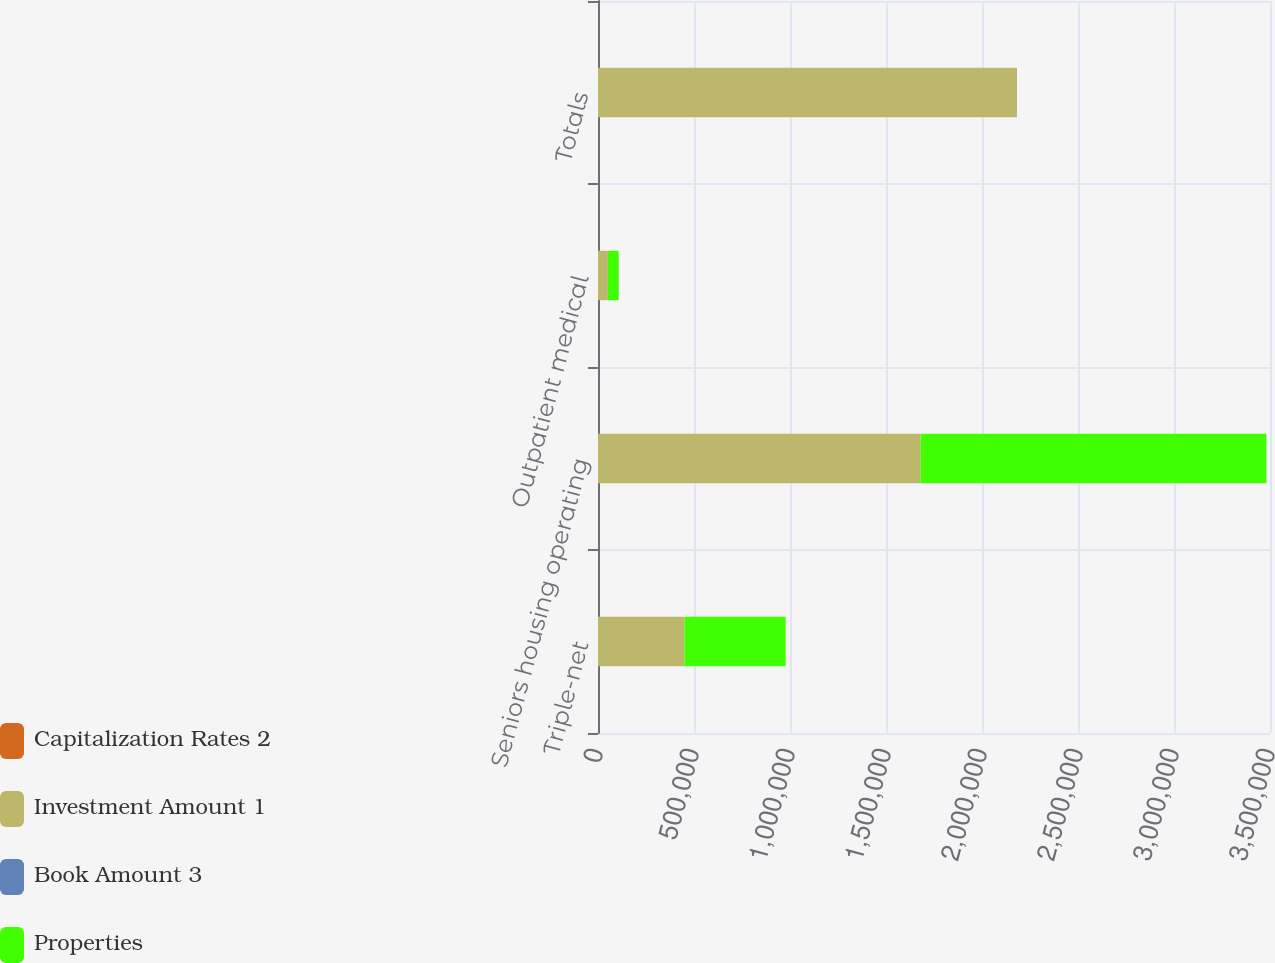Convert chart to OTSL. <chart><loc_0><loc_0><loc_500><loc_500><stacked_bar_chart><ecel><fcel>Triple-net<fcel>Seniors housing operating<fcel>Outpatient medical<fcel>Totals<nl><fcel>Capitalization Rates 2<fcel>14<fcel>34<fcel>3<fcel>51<nl><fcel>Investment Amount 1<fcel>450537<fcel>1.68016e+06<fcel>51434<fcel>2.18214e+06<nl><fcel>Book Amount 3<fcel>6.7<fcel>6.2<fcel>6.3<fcel>6.3<nl><fcel>Properties<fcel>526814<fcel>1.80145e+06<fcel>56386<fcel>51<nl></chart> 